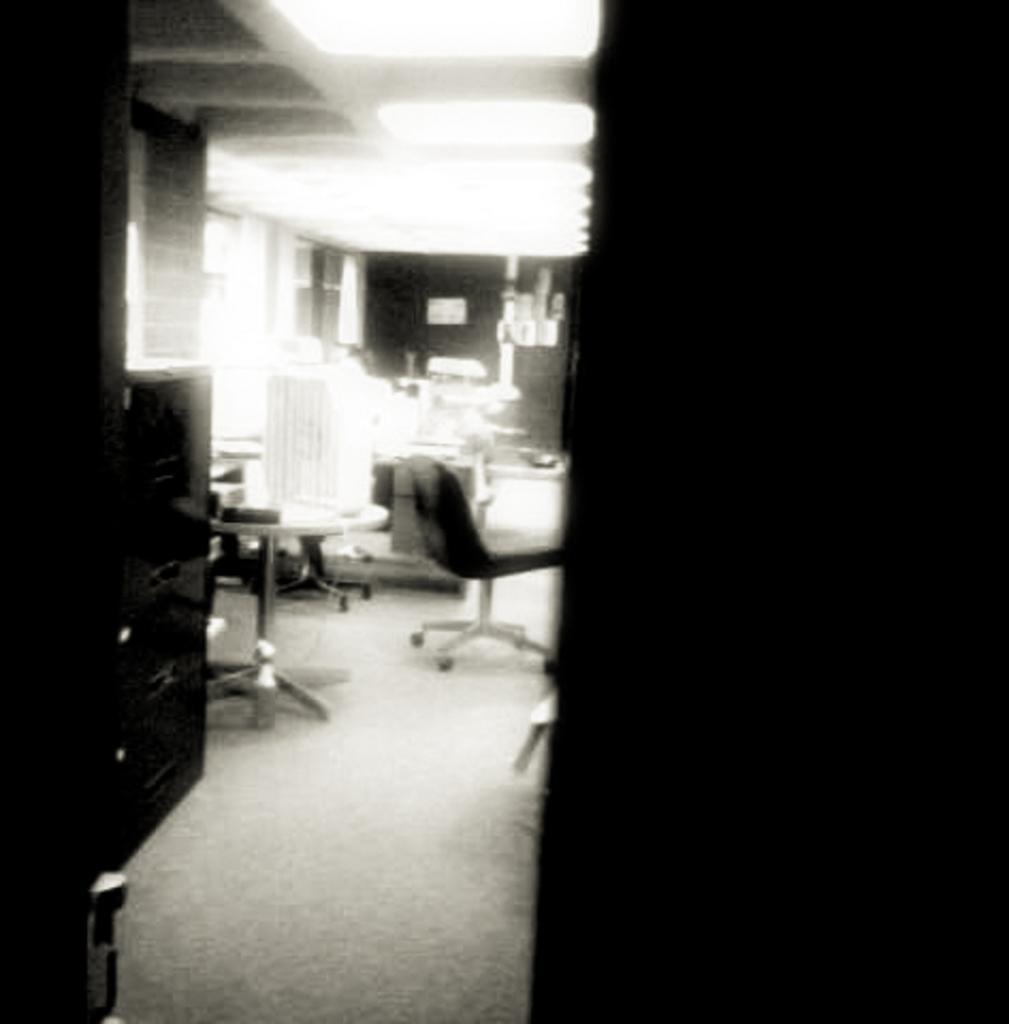Describe this image in one or two sentences. In this picture I can see chairs, tables and some objects on the floor. This image is black and white in color. 